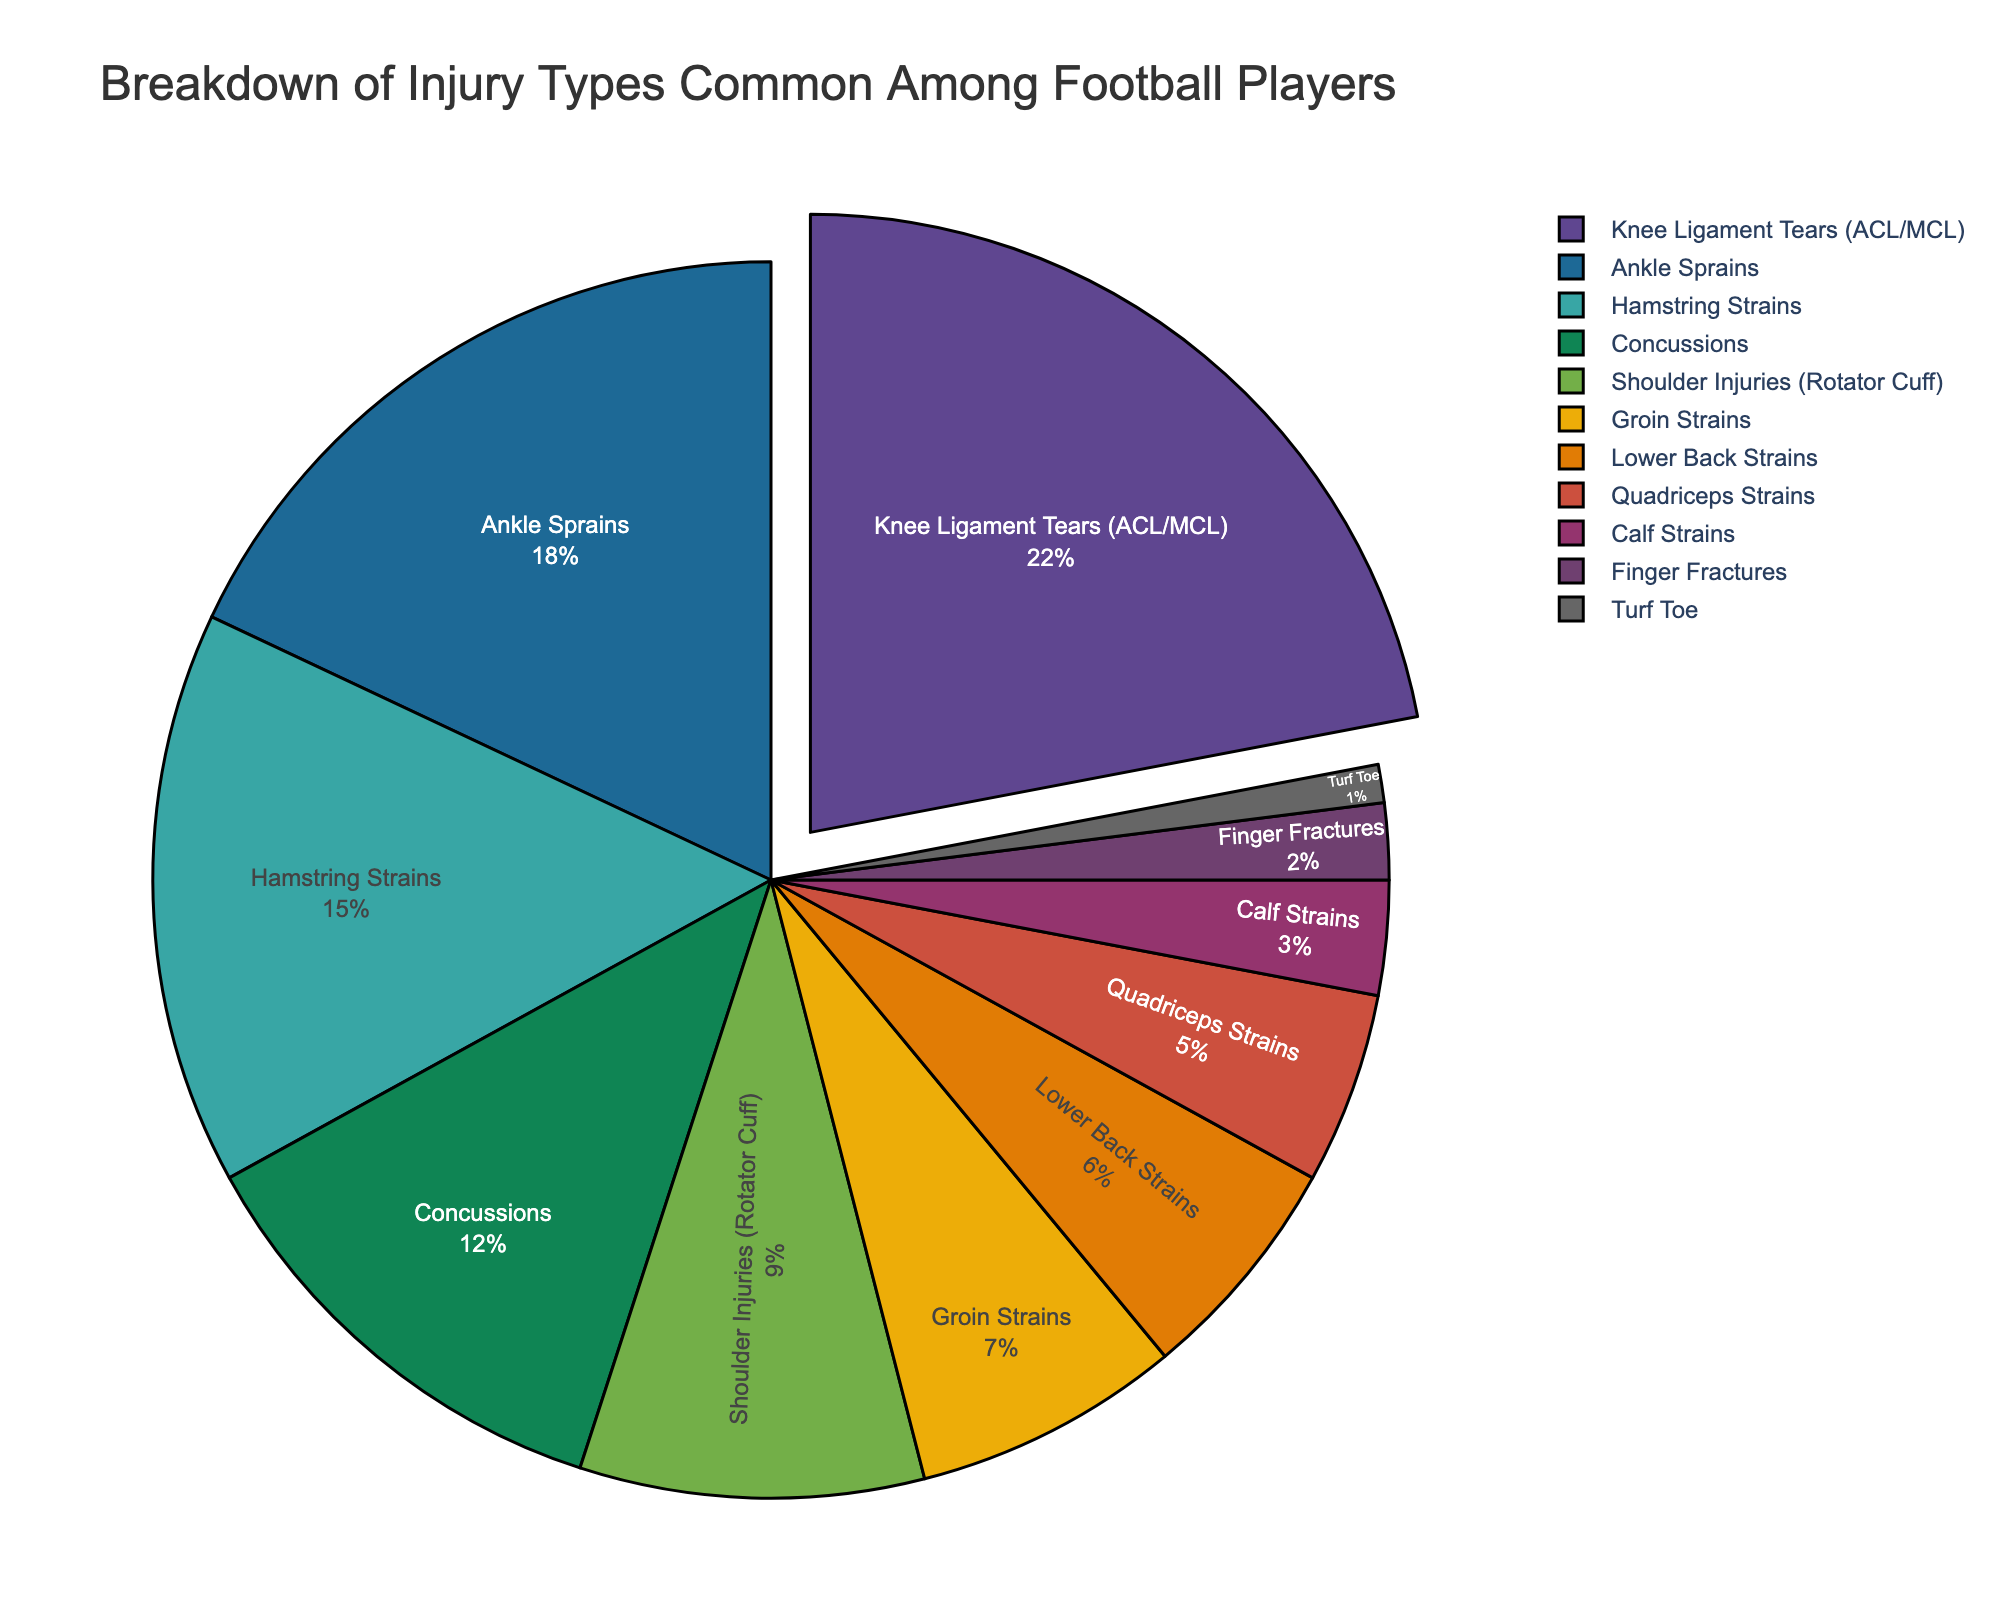What's the most common injury type among football players? The largest slice of the pie represents the most common injury type. In this chart, the "Knee Ligament Tears (ACL/MCL)" section is the largest.
Answer: Knee Ligament Tears (ACL/MCL) Which injury type accounts for the smallest percentage? The smallest slice in the pie chart represents the least common injury type. Here, "Turf Toe" has the smallest slice.
Answer: Turf Toe Are there more ankle sprains or hamstring strains? Compare the sizes of the slices for "Ankle Sprains" and "Hamstring Strains". The "Ankle Sprains" slice is larger than the "Hamstring Strains" slice.
Answer: Ankle Sprains What overall percentage do knee ligament tears and ankle sprains make up together? Add the percentages of "Knee Ligament Tears (ACL/MCL)" (22%) and "Ankle Sprains" (18%). The total is 22 + 18 = 40%.
Answer: 40% Is the percentage of concussions higher or lower than shoulder injuries? Compare the percentages of "Concussions" (12%) and "Shoulder Injuries (Rotator Cuff)" (9%). Concussions have a higher percentage.
Answer: Higher Which injuries make up more than 10% each? Look for injury types with percentage values greater than 10%. "Knee Ligament Tears (ACL/MCL)" (22%), "Ankle Sprains" (18%), "Hamstring Strains" (15%), and "Concussions" (12%) all meet this criterion.
Answer: Knee Ligament Tears (ACL/MCL), Ankle Sprains, Hamstring Strains, Concussions What is the combined percentage of injuries that involves the lower body? Add the percentages of "Knee Ligament Tears (ACL/MCL)" (22%), "Ankle Sprains" (18%), "Hamstring Strains" (15%), "Groin Strains" (7%), "Quadriceps Strains" (5%), "Calf Strains" (3%), and "Turf Toe" (1%). The total is 22 + 18 + 15 + 7 + 5 + 3 + 1 = 71%.
Answer: 71% Is the percentage of groin strains greater than, less than, or equal to lower back strains? Compare the percentages of "Groin Strains" (7%) and "Lower Back Strains" (6%). Groin strains have a slightly higher percentage.
Answer: Greater Which injury types collectively make up exactly 50% of the injuries? Add percentages of various combinations to find which total 50%. "Knee Ligament Tears (ACL/MCL)" (22%) + "Ankle Sprains" (18%) + "Hamstring Strains" (15%) = 55%, "Knee Ligament Tears (ACL/MCL)" (22%) + "Ankle Sprains" (18%) + "Concussions" (12%) = 52%, and finally, "Hamstring Strains" (15%) + "Concussions" (12%) + "Shoulder Injuries (Rotator Cuff)" (9%) + "Groin Strains" (7%) + "Lower Back Strains" (6%) + "Quadriceps Strains" (5%) + "Calf Strains" (3%) + "Finger Fractures" (2%) = 62%. Addition of "Ankle Sprains" (18%) + "Hamstring Strains" (15%) + "Concussions" (12%) + "Shoulder Injuries (Rotator Cuff)" (9%) = 54%. No specific combination adds to exactly 50%.
Answer: No specific combination What's the ratio of knee ligament tears to shoulder injuries? Divide the percentage of "Knee Ligament Tears (ACL/MCL)" (22%) by "Shoulder Injuries (Rotator Cuff)" (9%). The ratio is \( \frac{22}{9} \approx 2.44 \).
Answer: 2.44 